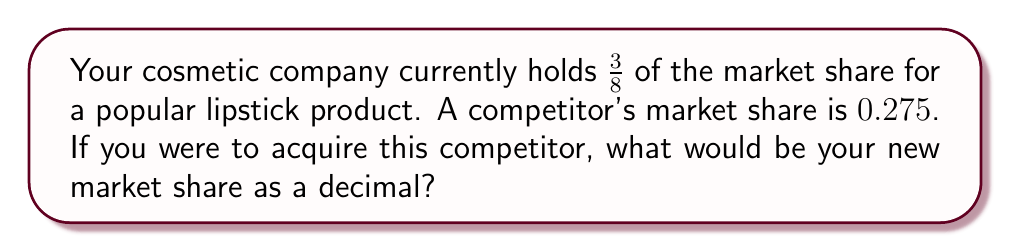Can you solve this math problem? To solve this problem, we need to follow these steps:

1. Convert the fraction $\frac{3}{8}$ to a decimal:
   $$\frac{3}{8} = 0.375$$

2. Add the decimal representation of your current market share to the competitor's market share:
   $$0.375 + 0.275 = 0.650$$

3. The result, 0.650, represents the new combined market share as a decimal.

This acquisition would increase your market share by 27.5 percentage points, from 37.5% to 65.0%, giving you a dominant position in the lipstick market.
Answer: 0.650 